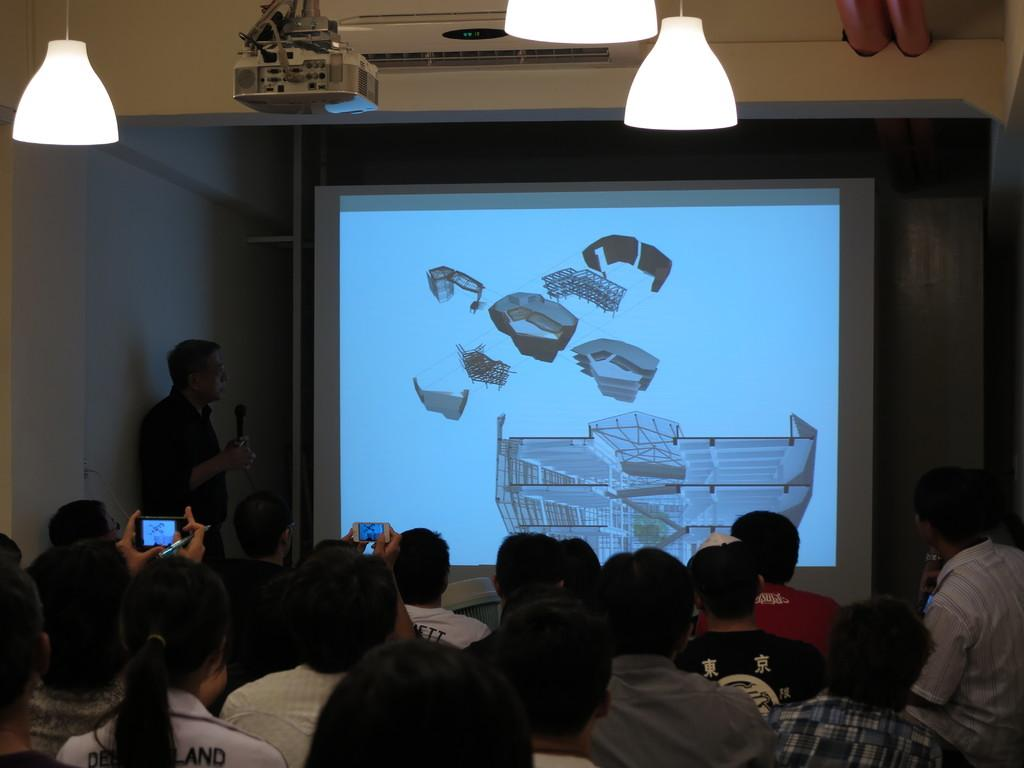What device is present in the image for displaying visual content? There is a projector in the image. What surface is used for displaying the projected content? There is a screen in the image for displaying the projected content. What type of illumination is present in the image? There are lights in the image. What device is present in the image for maintaining a comfortable temperature? There is an air conditioner in the image. Are there any people visible in the image? Yes, there are people in the image. What type of vegetable is being used as a prop by the actor in the image? There is no actor or vegetable present in the image. What emotion is displayed by the people in the image? The provided facts do not mention any emotions displayed by the people in the image. 